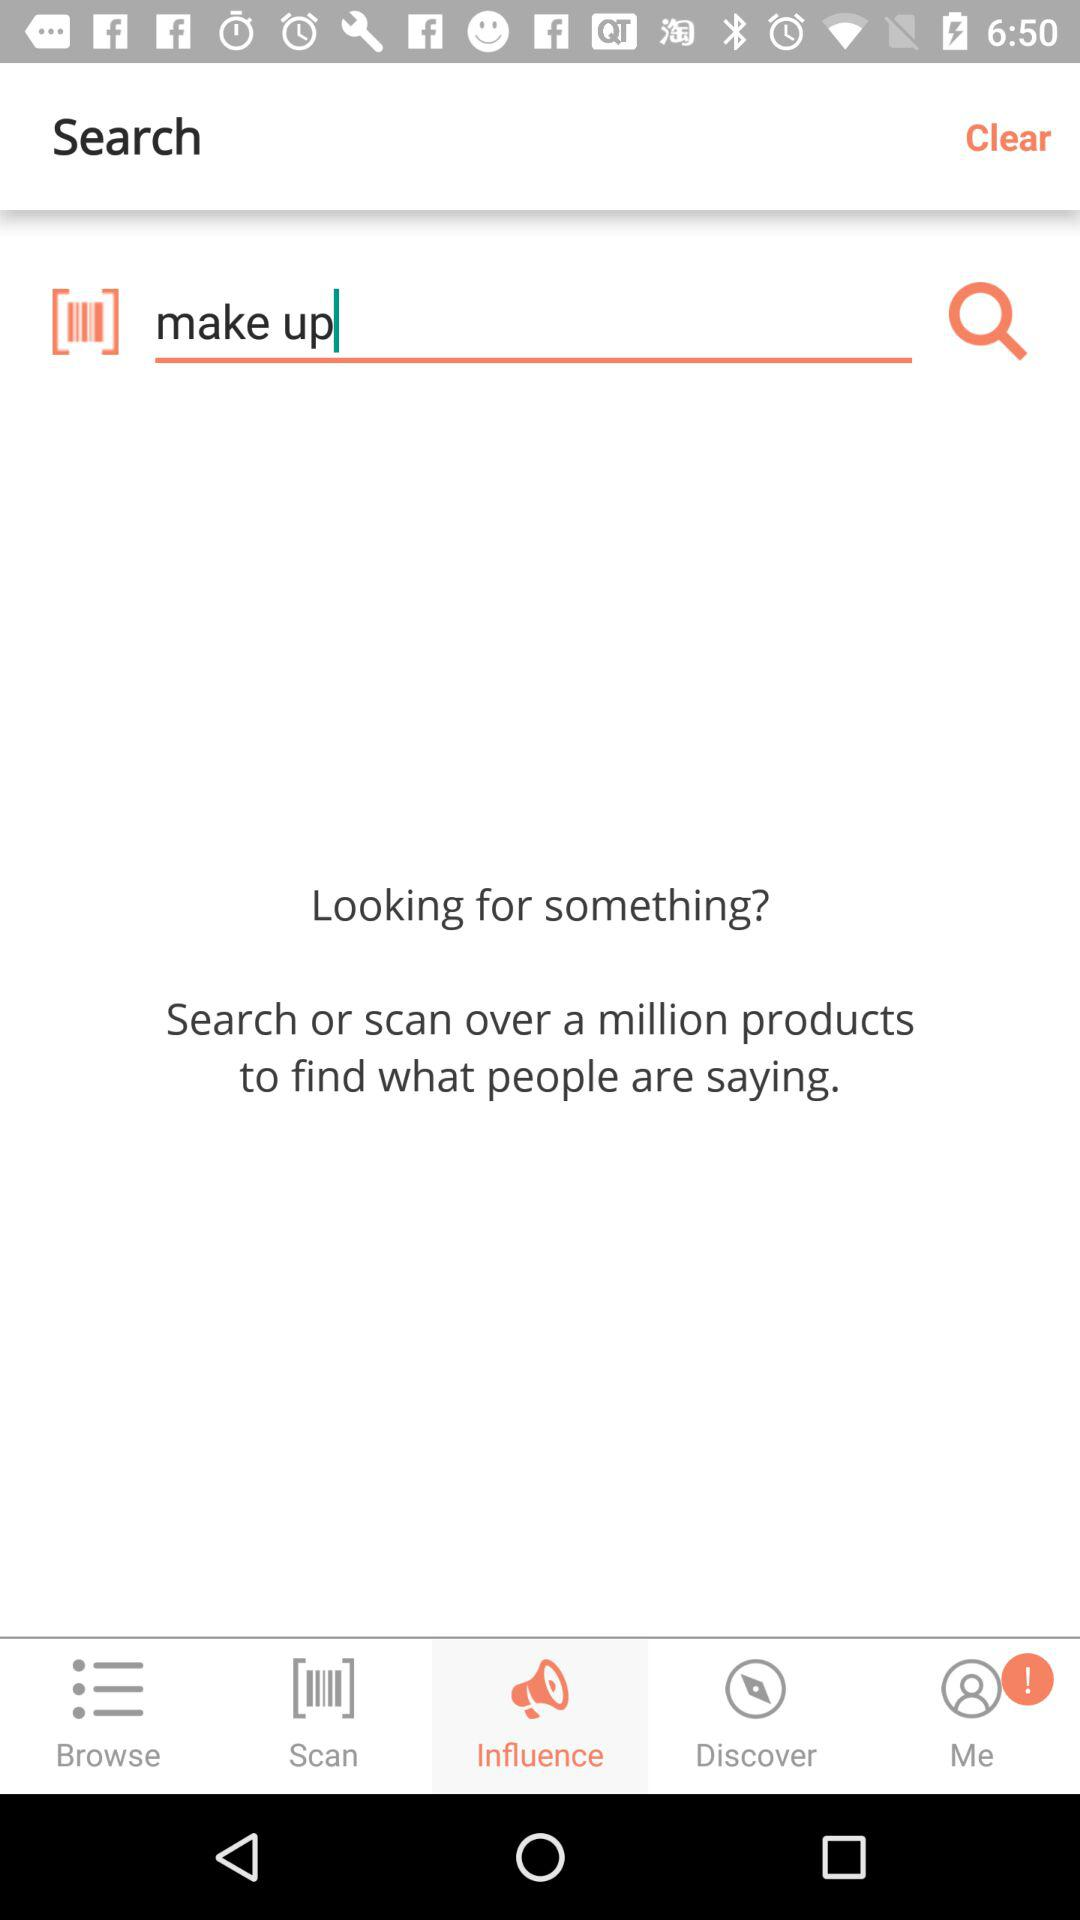Which word is the person searching for? The person is searching for the word "make up". 